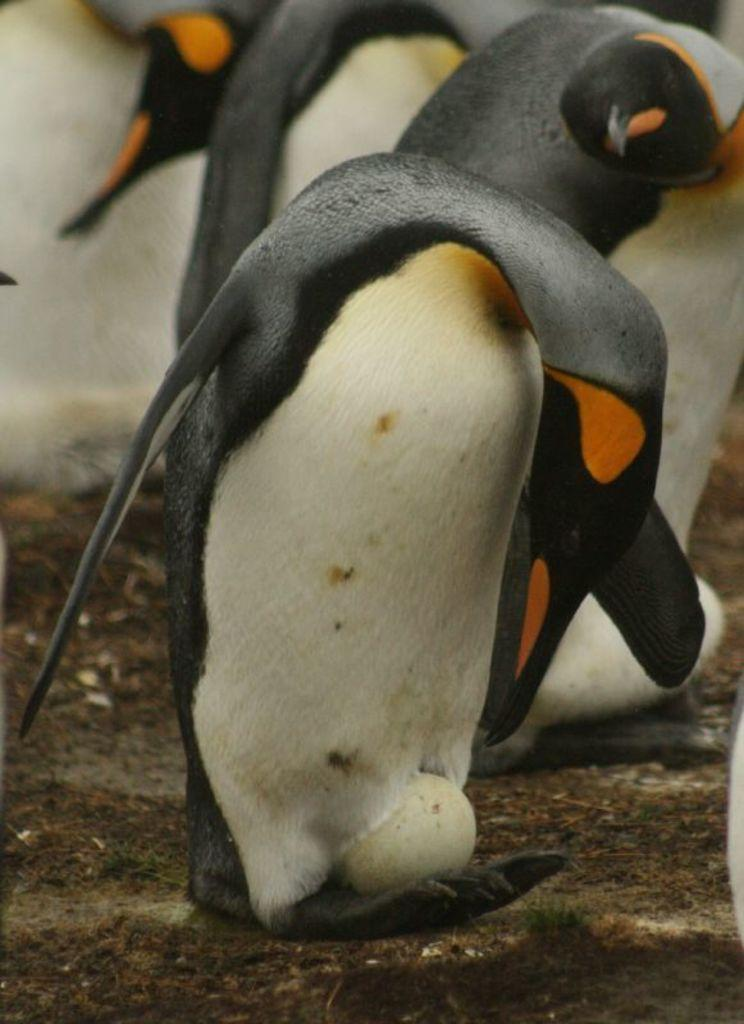What is the main subject in the center of the image? There is a penguin in the center of the image. What is the penguin in the center holding or carrying? The penguin in the center has an egg on its legs. Are there any other penguins visible in the image? Yes, there are penguins in the background area. What type of drug is the penguin in the center using in the image? There is no drug present in the image; it features a penguin with an egg on its legs. 